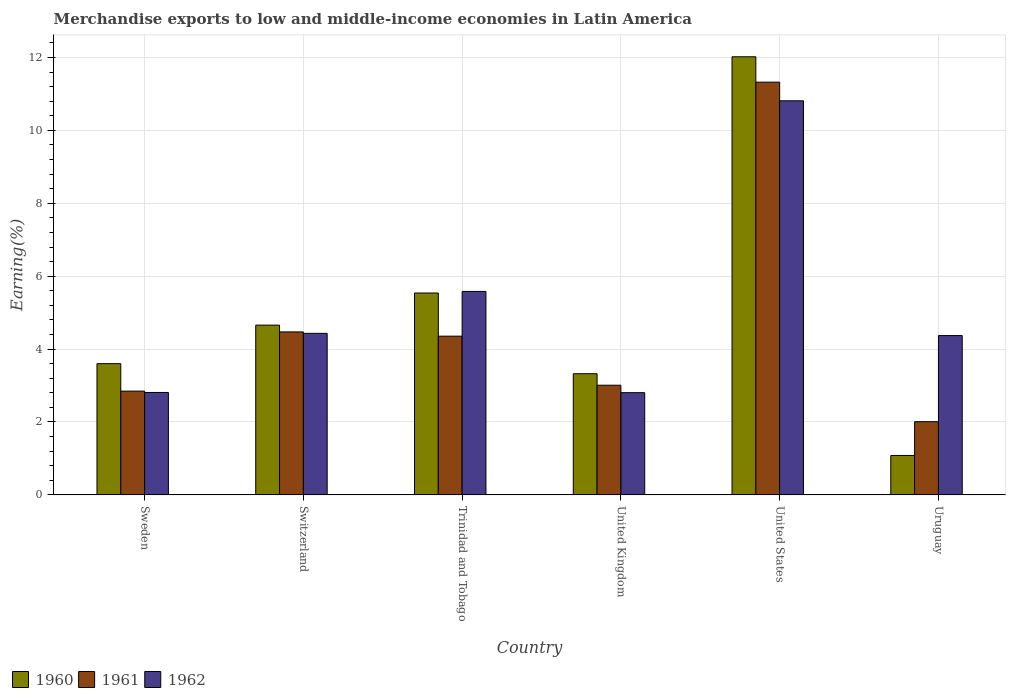How many different coloured bars are there?
Provide a succinct answer. 3. How many groups of bars are there?
Your response must be concise. 6. What is the label of the 6th group of bars from the left?
Your answer should be compact. Uruguay. In how many cases, is the number of bars for a given country not equal to the number of legend labels?
Your answer should be compact. 0. What is the percentage of amount earned from merchandise exports in 1962 in United States?
Your answer should be very brief. 10.81. Across all countries, what is the maximum percentage of amount earned from merchandise exports in 1962?
Make the answer very short. 10.81. Across all countries, what is the minimum percentage of amount earned from merchandise exports in 1960?
Provide a succinct answer. 1.08. In which country was the percentage of amount earned from merchandise exports in 1961 minimum?
Offer a terse response. Uruguay. What is the total percentage of amount earned from merchandise exports in 1961 in the graph?
Ensure brevity in your answer.  28.01. What is the difference between the percentage of amount earned from merchandise exports in 1961 in Sweden and that in United Kingdom?
Offer a terse response. -0.16. What is the difference between the percentage of amount earned from merchandise exports in 1961 in United States and the percentage of amount earned from merchandise exports in 1962 in United Kingdom?
Provide a succinct answer. 8.52. What is the average percentage of amount earned from merchandise exports in 1962 per country?
Your answer should be very brief. 5.13. What is the difference between the percentage of amount earned from merchandise exports of/in 1960 and percentage of amount earned from merchandise exports of/in 1962 in United States?
Your answer should be compact. 1.21. What is the ratio of the percentage of amount earned from merchandise exports in 1960 in Switzerland to that in Trinidad and Tobago?
Your answer should be compact. 0.84. Is the difference between the percentage of amount earned from merchandise exports in 1960 in Trinidad and Tobago and United States greater than the difference between the percentage of amount earned from merchandise exports in 1962 in Trinidad and Tobago and United States?
Provide a succinct answer. No. What is the difference between the highest and the second highest percentage of amount earned from merchandise exports in 1960?
Provide a succinct answer. 6.48. What is the difference between the highest and the lowest percentage of amount earned from merchandise exports in 1960?
Offer a terse response. 10.94. In how many countries, is the percentage of amount earned from merchandise exports in 1962 greater than the average percentage of amount earned from merchandise exports in 1962 taken over all countries?
Your answer should be compact. 2. What does the 1st bar from the right in Trinidad and Tobago represents?
Provide a short and direct response. 1962. Is it the case that in every country, the sum of the percentage of amount earned from merchandise exports in 1961 and percentage of amount earned from merchandise exports in 1960 is greater than the percentage of amount earned from merchandise exports in 1962?
Keep it short and to the point. No. How many bars are there?
Your answer should be very brief. 18. Are all the bars in the graph horizontal?
Ensure brevity in your answer.  No. What is the difference between two consecutive major ticks on the Y-axis?
Ensure brevity in your answer.  2. Does the graph contain any zero values?
Ensure brevity in your answer.  No. Does the graph contain grids?
Keep it short and to the point. Yes. What is the title of the graph?
Give a very brief answer. Merchandise exports to low and middle-income economies in Latin America. What is the label or title of the Y-axis?
Your answer should be compact. Earning(%). What is the Earning(%) of 1960 in Sweden?
Offer a very short reply. 3.6. What is the Earning(%) of 1961 in Sweden?
Make the answer very short. 2.85. What is the Earning(%) in 1962 in Sweden?
Offer a very short reply. 2.81. What is the Earning(%) in 1960 in Switzerland?
Your answer should be very brief. 4.66. What is the Earning(%) of 1961 in Switzerland?
Your answer should be very brief. 4.47. What is the Earning(%) in 1962 in Switzerland?
Make the answer very short. 4.43. What is the Earning(%) of 1960 in Trinidad and Tobago?
Keep it short and to the point. 5.54. What is the Earning(%) of 1961 in Trinidad and Tobago?
Your answer should be compact. 4.35. What is the Earning(%) in 1962 in Trinidad and Tobago?
Provide a short and direct response. 5.58. What is the Earning(%) in 1960 in United Kingdom?
Offer a terse response. 3.32. What is the Earning(%) in 1961 in United Kingdom?
Keep it short and to the point. 3.01. What is the Earning(%) of 1962 in United Kingdom?
Make the answer very short. 2.8. What is the Earning(%) of 1960 in United States?
Ensure brevity in your answer.  12.02. What is the Earning(%) of 1961 in United States?
Your response must be concise. 11.32. What is the Earning(%) of 1962 in United States?
Ensure brevity in your answer.  10.81. What is the Earning(%) in 1960 in Uruguay?
Your answer should be compact. 1.08. What is the Earning(%) of 1961 in Uruguay?
Your answer should be compact. 2.01. What is the Earning(%) in 1962 in Uruguay?
Your response must be concise. 4.37. Across all countries, what is the maximum Earning(%) of 1960?
Your response must be concise. 12.02. Across all countries, what is the maximum Earning(%) of 1961?
Your answer should be compact. 11.32. Across all countries, what is the maximum Earning(%) in 1962?
Ensure brevity in your answer.  10.81. Across all countries, what is the minimum Earning(%) of 1960?
Your answer should be compact. 1.08. Across all countries, what is the minimum Earning(%) in 1961?
Keep it short and to the point. 2.01. Across all countries, what is the minimum Earning(%) in 1962?
Provide a succinct answer. 2.8. What is the total Earning(%) in 1960 in the graph?
Make the answer very short. 30.22. What is the total Earning(%) in 1961 in the graph?
Make the answer very short. 28.01. What is the total Earning(%) in 1962 in the graph?
Ensure brevity in your answer.  30.81. What is the difference between the Earning(%) of 1960 in Sweden and that in Switzerland?
Your answer should be compact. -1.06. What is the difference between the Earning(%) in 1961 in Sweden and that in Switzerland?
Make the answer very short. -1.62. What is the difference between the Earning(%) of 1962 in Sweden and that in Switzerland?
Provide a succinct answer. -1.62. What is the difference between the Earning(%) of 1960 in Sweden and that in Trinidad and Tobago?
Your response must be concise. -1.94. What is the difference between the Earning(%) of 1961 in Sweden and that in Trinidad and Tobago?
Offer a terse response. -1.51. What is the difference between the Earning(%) in 1962 in Sweden and that in Trinidad and Tobago?
Your response must be concise. -2.77. What is the difference between the Earning(%) of 1960 in Sweden and that in United Kingdom?
Offer a terse response. 0.28. What is the difference between the Earning(%) in 1961 in Sweden and that in United Kingdom?
Offer a very short reply. -0.16. What is the difference between the Earning(%) in 1962 in Sweden and that in United Kingdom?
Your answer should be very brief. 0.01. What is the difference between the Earning(%) of 1960 in Sweden and that in United States?
Provide a succinct answer. -8.42. What is the difference between the Earning(%) in 1961 in Sweden and that in United States?
Provide a short and direct response. -8.47. What is the difference between the Earning(%) of 1962 in Sweden and that in United States?
Your answer should be very brief. -8. What is the difference between the Earning(%) in 1960 in Sweden and that in Uruguay?
Make the answer very short. 2.52. What is the difference between the Earning(%) of 1961 in Sweden and that in Uruguay?
Your response must be concise. 0.84. What is the difference between the Earning(%) of 1962 in Sweden and that in Uruguay?
Give a very brief answer. -1.56. What is the difference between the Earning(%) in 1960 in Switzerland and that in Trinidad and Tobago?
Provide a succinct answer. -0.88. What is the difference between the Earning(%) in 1961 in Switzerland and that in Trinidad and Tobago?
Offer a terse response. 0.12. What is the difference between the Earning(%) in 1962 in Switzerland and that in Trinidad and Tobago?
Your answer should be very brief. -1.15. What is the difference between the Earning(%) in 1960 in Switzerland and that in United Kingdom?
Provide a succinct answer. 1.33. What is the difference between the Earning(%) in 1961 in Switzerland and that in United Kingdom?
Provide a short and direct response. 1.46. What is the difference between the Earning(%) of 1962 in Switzerland and that in United Kingdom?
Your answer should be compact. 1.63. What is the difference between the Earning(%) of 1960 in Switzerland and that in United States?
Ensure brevity in your answer.  -7.36. What is the difference between the Earning(%) in 1961 in Switzerland and that in United States?
Provide a short and direct response. -6.85. What is the difference between the Earning(%) in 1962 in Switzerland and that in United States?
Offer a very short reply. -6.38. What is the difference between the Earning(%) in 1960 in Switzerland and that in Uruguay?
Provide a short and direct response. 3.58. What is the difference between the Earning(%) of 1961 in Switzerland and that in Uruguay?
Give a very brief answer. 2.46. What is the difference between the Earning(%) of 1962 in Switzerland and that in Uruguay?
Provide a short and direct response. 0.06. What is the difference between the Earning(%) of 1960 in Trinidad and Tobago and that in United Kingdom?
Provide a short and direct response. 2.21. What is the difference between the Earning(%) in 1961 in Trinidad and Tobago and that in United Kingdom?
Your response must be concise. 1.35. What is the difference between the Earning(%) in 1962 in Trinidad and Tobago and that in United Kingdom?
Your response must be concise. 2.78. What is the difference between the Earning(%) of 1960 in Trinidad and Tobago and that in United States?
Keep it short and to the point. -6.48. What is the difference between the Earning(%) in 1961 in Trinidad and Tobago and that in United States?
Provide a succinct answer. -6.97. What is the difference between the Earning(%) in 1962 in Trinidad and Tobago and that in United States?
Offer a very short reply. -5.23. What is the difference between the Earning(%) of 1960 in Trinidad and Tobago and that in Uruguay?
Provide a succinct answer. 4.46. What is the difference between the Earning(%) of 1961 in Trinidad and Tobago and that in Uruguay?
Offer a terse response. 2.35. What is the difference between the Earning(%) of 1962 in Trinidad and Tobago and that in Uruguay?
Offer a very short reply. 1.21. What is the difference between the Earning(%) of 1960 in United Kingdom and that in United States?
Give a very brief answer. -8.69. What is the difference between the Earning(%) of 1961 in United Kingdom and that in United States?
Keep it short and to the point. -8.31. What is the difference between the Earning(%) in 1962 in United Kingdom and that in United States?
Offer a terse response. -8.01. What is the difference between the Earning(%) of 1960 in United Kingdom and that in Uruguay?
Give a very brief answer. 2.24. What is the difference between the Earning(%) of 1962 in United Kingdom and that in Uruguay?
Offer a terse response. -1.57. What is the difference between the Earning(%) in 1960 in United States and that in Uruguay?
Offer a very short reply. 10.94. What is the difference between the Earning(%) of 1961 in United States and that in Uruguay?
Provide a short and direct response. 9.31. What is the difference between the Earning(%) of 1962 in United States and that in Uruguay?
Ensure brevity in your answer.  6.44. What is the difference between the Earning(%) of 1960 in Sweden and the Earning(%) of 1961 in Switzerland?
Your response must be concise. -0.87. What is the difference between the Earning(%) of 1960 in Sweden and the Earning(%) of 1962 in Switzerland?
Your response must be concise. -0.83. What is the difference between the Earning(%) of 1961 in Sweden and the Earning(%) of 1962 in Switzerland?
Provide a short and direct response. -1.58. What is the difference between the Earning(%) in 1960 in Sweden and the Earning(%) in 1961 in Trinidad and Tobago?
Offer a terse response. -0.75. What is the difference between the Earning(%) in 1960 in Sweden and the Earning(%) in 1962 in Trinidad and Tobago?
Provide a short and direct response. -1.98. What is the difference between the Earning(%) in 1961 in Sweden and the Earning(%) in 1962 in Trinidad and Tobago?
Give a very brief answer. -2.73. What is the difference between the Earning(%) in 1960 in Sweden and the Earning(%) in 1961 in United Kingdom?
Provide a succinct answer. 0.59. What is the difference between the Earning(%) of 1960 in Sweden and the Earning(%) of 1962 in United Kingdom?
Ensure brevity in your answer.  0.8. What is the difference between the Earning(%) in 1961 in Sweden and the Earning(%) in 1962 in United Kingdom?
Make the answer very short. 0.04. What is the difference between the Earning(%) in 1960 in Sweden and the Earning(%) in 1961 in United States?
Offer a terse response. -7.72. What is the difference between the Earning(%) of 1960 in Sweden and the Earning(%) of 1962 in United States?
Keep it short and to the point. -7.21. What is the difference between the Earning(%) of 1961 in Sweden and the Earning(%) of 1962 in United States?
Keep it short and to the point. -7.96. What is the difference between the Earning(%) of 1960 in Sweden and the Earning(%) of 1961 in Uruguay?
Your response must be concise. 1.59. What is the difference between the Earning(%) in 1960 in Sweden and the Earning(%) in 1962 in Uruguay?
Make the answer very short. -0.77. What is the difference between the Earning(%) in 1961 in Sweden and the Earning(%) in 1962 in Uruguay?
Your answer should be very brief. -1.52. What is the difference between the Earning(%) of 1960 in Switzerland and the Earning(%) of 1961 in Trinidad and Tobago?
Provide a succinct answer. 0.3. What is the difference between the Earning(%) of 1960 in Switzerland and the Earning(%) of 1962 in Trinidad and Tobago?
Keep it short and to the point. -0.92. What is the difference between the Earning(%) of 1961 in Switzerland and the Earning(%) of 1962 in Trinidad and Tobago?
Your answer should be compact. -1.11. What is the difference between the Earning(%) in 1960 in Switzerland and the Earning(%) in 1961 in United Kingdom?
Offer a very short reply. 1.65. What is the difference between the Earning(%) in 1960 in Switzerland and the Earning(%) in 1962 in United Kingdom?
Make the answer very short. 1.85. What is the difference between the Earning(%) in 1961 in Switzerland and the Earning(%) in 1962 in United Kingdom?
Make the answer very short. 1.67. What is the difference between the Earning(%) of 1960 in Switzerland and the Earning(%) of 1961 in United States?
Provide a succinct answer. -6.67. What is the difference between the Earning(%) in 1960 in Switzerland and the Earning(%) in 1962 in United States?
Keep it short and to the point. -6.15. What is the difference between the Earning(%) of 1961 in Switzerland and the Earning(%) of 1962 in United States?
Your answer should be very brief. -6.34. What is the difference between the Earning(%) of 1960 in Switzerland and the Earning(%) of 1961 in Uruguay?
Offer a terse response. 2.65. What is the difference between the Earning(%) of 1960 in Switzerland and the Earning(%) of 1962 in Uruguay?
Keep it short and to the point. 0.29. What is the difference between the Earning(%) of 1961 in Switzerland and the Earning(%) of 1962 in Uruguay?
Offer a very short reply. 0.1. What is the difference between the Earning(%) of 1960 in Trinidad and Tobago and the Earning(%) of 1961 in United Kingdom?
Your answer should be very brief. 2.53. What is the difference between the Earning(%) in 1960 in Trinidad and Tobago and the Earning(%) in 1962 in United Kingdom?
Your answer should be compact. 2.73. What is the difference between the Earning(%) of 1961 in Trinidad and Tobago and the Earning(%) of 1962 in United Kingdom?
Keep it short and to the point. 1.55. What is the difference between the Earning(%) of 1960 in Trinidad and Tobago and the Earning(%) of 1961 in United States?
Your response must be concise. -5.78. What is the difference between the Earning(%) in 1960 in Trinidad and Tobago and the Earning(%) in 1962 in United States?
Provide a short and direct response. -5.27. What is the difference between the Earning(%) of 1961 in Trinidad and Tobago and the Earning(%) of 1962 in United States?
Ensure brevity in your answer.  -6.46. What is the difference between the Earning(%) of 1960 in Trinidad and Tobago and the Earning(%) of 1961 in Uruguay?
Your answer should be compact. 3.53. What is the difference between the Earning(%) of 1960 in Trinidad and Tobago and the Earning(%) of 1962 in Uruguay?
Your answer should be compact. 1.17. What is the difference between the Earning(%) of 1961 in Trinidad and Tobago and the Earning(%) of 1962 in Uruguay?
Provide a short and direct response. -0.02. What is the difference between the Earning(%) of 1960 in United Kingdom and the Earning(%) of 1961 in United States?
Your answer should be very brief. -8. What is the difference between the Earning(%) of 1960 in United Kingdom and the Earning(%) of 1962 in United States?
Offer a terse response. -7.49. What is the difference between the Earning(%) of 1961 in United Kingdom and the Earning(%) of 1962 in United States?
Your answer should be very brief. -7.8. What is the difference between the Earning(%) of 1960 in United Kingdom and the Earning(%) of 1961 in Uruguay?
Ensure brevity in your answer.  1.32. What is the difference between the Earning(%) in 1960 in United Kingdom and the Earning(%) in 1962 in Uruguay?
Your response must be concise. -1.05. What is the difference between the Earning(%) in 1961 in United Kingdom and the Earning(%) in 1962 in Uruguay?
Ensure brevity in your answer.  -1.36. What is the difference between the Earning(%) in 1960 in United States and the Earning(%) in 1961 in Uruguay?
Your answer should be compact. 10.01. What is the difference between the Earning(%) of 1960 in United States and the Earning(%) of 1962 in Uruguay?
Offer a very short reply. 7.65. What is the difference between the Earning(%) of 1961 in United States and the Earning(%) of 1962 in Uruguay?
Make the answer very short. 6.95. What is the average Earning(%) of 1960 per country?
Keep it short and to the point. 5.04. What is the average Earning(%) in 1961 per country?
Your response must be concise. 4.67. What is the average Earning(%) of 1962 per country?
Provide a short and direct response. 5.13. What is the difference between the Earning(%) in 1960 and Earning(%) in 1961 in Sweden?
Keep it short and to the point. 0.75. What is the difference between the Earning(%) in 1960 and Earning(%) in 1962 in Sweden?
Your answer should be very brief. 0.79. What is the difference between the Earning(%) of 1961 and Earning(%) of 1962 in Sweden?
Keep it short and to the point. 0.04. What is the difference between the Earning(%) in 1960 and Earning(%) in 1961 in Switzerland?
Your answer should be very brief. 0.19. What is the difference between the Earning(%) of 1960 and Earning(%) of 1962 in Switzerland?
Offer a very short reply. 0.23. What is the difference between the Earning(%) of 1961 and Earning(%) of 1962 in Switzerland?
Your answer should be compact. 0.04. What is the difference between the Earning(%) of 1960 and Earning(%) of 1961 in Trinidad and Tobago?
Make the answer very short. 1.18. What is the difference between the Earning(%) of 1960 and Earning(%) of 1962 in Trinidad and Tobago?
Your answer should be very brief. -0.04. What is the difference between the Earning(%) of 1961 and Earning(%) of 1962 in Trinidad and Tobago?
Make the answer very short. -1.23. What is the difference between the Earning(%) in 1960 and Earning(%) in 1961 in United Kingdom?
Your answer should be very brief. 0.32. What is the difference between the Earning(%) in 1960 and Earning(%) in 1962 in United Kingdom?
Ensure brevity in your answer.  0.52. What is the difference between the Earning(%) of 1961 and Earning(%) of 1962 in United Kingdom?
Offer a very short reply. 0.2. What is the difference between the Earning(%) in 1960 and Earning(%) in 1961 in United States?
Your answer should be very brief. 0.7. What is the difference between the Earning(%) in 1960 and Earning(%) in 1962 in United States?
Ensure brevity in your answer.  1.21. What is the difference between the Earning(%) in 1961 and Earning(%) in 1962 in United States?
Your response must be concise. 0.51. What is the difference between the Earning(%) of 1960 and Earning(%) of 1961 in Uruguay?
Your answer should be very brief. -0.93. What is the difference between the Earning(%) of 1960 and Earning(%) of 1962 in Uruguay?
Make the answer very short. -3.29. What is the difference between the Earning(%) of 1961 and Earning(%) of 1962 in Uruguay?
Offer a terse response. -2.36. What is the ratio of the Earning(%) of 1960 in Sweden to that in Switzerland?
Offer a very short reply. 0.77. What is the ratio of the Earning(%) in 1961 in Sweden to that in Switzerland?
Keep it short and to the point. 0.64. What is the ratio of the Earning(%) in 1962 in Sweden to that in Switzerland?
Your response must be concise. 0.63. What is the ratio of the Earning(%) in 1960 in Sweden to that in Trinidad and Tobago?
Your answer should be compact. 0.65. What is the ratio of the Earning(%) of 1961 in Sweden to that in Trinidad and Tobago?
Provide a succinct answer. 0.65. What is the ratio of the Earning(%) in 1962 in Sweden to that in Trinidad and Tobago?
Make the answer very short. 0.5. What is the ratio of the Earning(%) in 1960 in Sweden to that in United Kingdom?
Provide a short and direct response. 1.08. What is the ratio of the Earning(%) of 1961 in Sweden to that in United Kingdom?
Offer a very short reply. 0.95. What is the ratio of the Earning(%) in 1962 in Sweden to that in United Kingdom?
Offer a terse response. 1. What is the ratio of the Earning(%) of 1960 in Sweden to that in United States?
Provide a succinct answer. 0.3. What is the ratio of the Earning(%) in 1961 in Sweden to that in United States?
Keep it short and to the point. 0.25. What is the ratio of the Earning(%) of 1962 in Sweden to that in United States?
Provide a short and direct response. 0.26. What is the ratio of the Earning(%) of 1960 in Sweden to that in Uruguay?
Offer a terse response. 3.33. What is the ratio of the Earning(%) in 1961 in Sweden to that in Uruguay?
Your response must be concise. 1.42. What is the ratio of the Earning(%) of 1962 in Sweden to that in Uruguay?
Offer a terse response. 0.64. What is the ratio of the Earning(%) in 1960 in Switzerland to that in Trinidad and Tobago?
Give a very brief answer. 0.84. What is the ratio of the Earning(%) in 1961 in Switzerland to that in Trinidad and Tobago?
Make the answer very short. 1.03. What is the ratio of the Earning(%) in 1962 in Switzerland to that in Trinidad and Tobago?
Keep it short and to the point. 0.79. What is the ratio of the Earning(%) of 1960 in Switzerland to that in United Kingdom?
Provide a short and direct response. 1.4. What is the ratio of the Earning(%) of 1961 in Switzerland to that in United Kingdom?
Offer a terse response. 1.49. What is the ratio of the Earning(%) in 1962 in Switzerland to that in United Kingdom?
Keep it short and to the point. 1.58. What is the ratio of the Earning(%) of 1960 in Switzerland to that in United States?
Ensure brevity in your answer.  0.39. What is the ratio of the Earning(%) in 1961 in Switzerland to that in United States?
Provide a succinct answer. 0.39. What is the ratio of the Earning(%) in 1962 in Switzerland to that in United States?
Your response must be concise. 0.41. What is the ratio of the Earning(%) of 1960 in Switzerland to that in Uruguay?
Ensure brevity in your answer.  4.31. What is the ratio of the Earning(%) in 1961 in Switzerland to that in Uruguay?
Offer a terse response. 2.23. What is the ratio of the Earning(%) in 1962 in Switzerland to that in Uruguay?
Provide a succinct answer. 1.01. What is the ratio of the Earning(%) of 1960 in Trinidad and Tobago to that in United Kingdom?
Offer a terse response. 1.67. What is the ratio of the Earning(%) in 1961 in Trinidad and Tobago to that in United Kingdom?
Make the answer very short. 1.45. What is the ratio of the Earning(%) of 1962 in Trinidad and Tobago to that in United Kingdom?
Make the answer very short. 1.99. What is the ratio of the Earning(%) in 1960 in Trinidad and Tobago to that in United States?
Make the answer very short. 0.46. What is the ratio of the Earning(%) in 1961 in Trinidad and Tobago to that in United States?
Your answer should be compact. 0.38. What is the ratio of the Earning(%) in 1962 in Trinidad and Tobago to that in United States?
Make the answer very short. 0.52. What is the ratio of the Earning(%) of 1960 in Trinidad and Tobago to that in Uruguay?
Keep it short and to the point. 5.12. What is the ratio of the Earning(%) in 1961 in Trinidad and Tobago to that in Uruguay?
Keep it short and to the point. 2.17. What is the ratio of the Earning(%) of 1962 in Trinidad and Tobago to that in Uruguay?
Provide a succinct answer. 1.28. What is the ratio of the Earning(%) in 1960 in United Kingdom to that in United States?
Your answer should be compact. 0.28. What is the ratio of the Earning(%) of 1961 in United Kingdom to that in United States?
Your answer should be very brief. 0.27. What is the ratio of the Earning(%) of 1962 in United Kingdom to that in United States?
Ensure brevity in your answer.  0.26. What is the ratio of the Earning(%) in 1960 in United Kingdom to that in Uruguay?
Give a very brief answer. 3.07. What is the ratio of the Earning(%) in 1961 in United Kingdom to that in Uruguay?
Ensure brevity in your answer.  1.5. What is the ratio of the Earning(%) in 1962 in United Kingdom to that in Uruguay?
Ensure brevity in your answer.  0.64. What is the ratio of the Earning(%) of 1960 in United States to that in Uruguay?
Offer a very short reply. 11.12. What is the ratio of the Earning(%) of 1961 in United States to that in Uruguay?
Your response must be concise. 5.64. What is the ratio of the Earning(%) of 1962 in United States to that in Uruguay?
Provide a short and direct response. 2.47. What is the difference between the highest and the second highest Earning(%) in 1960?
Your response must be concise. 6.48. What is the difference between the highest and the second highest Earning(%) in 1961?
Give a very brief answer. 6.85. What is the difference between the highest and the second highest Earning(%) in 1962?
Offer a terse response. 5.23. What is the difference between the highest and the lowest Earning(%) of 1960?
Your answer should be compact. 10.94. What is the difference between the highest and the lowest Earning(%) in 1961?
Ensure brevity in your answer.  9.31. What is the difference between the highest and the lowest Earning(%) of 1962?
Make the answer very short. 8.01. 